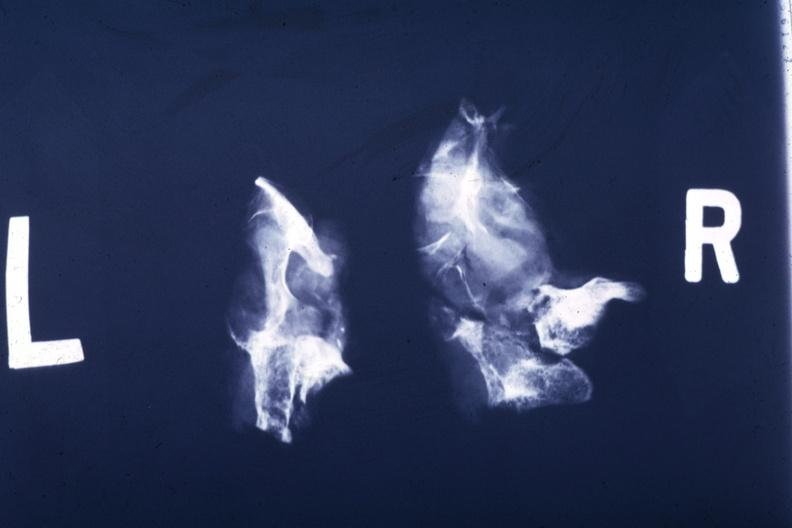what is present?
Answer the question using a single word or phrase. Endocrine 